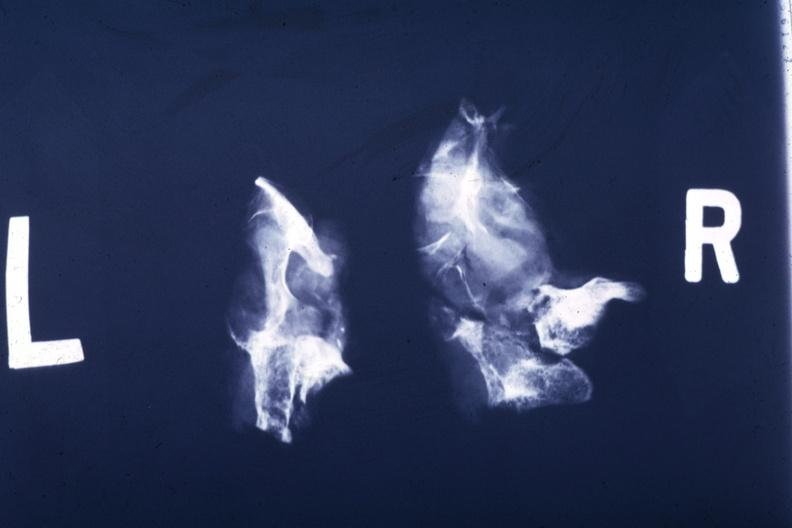what is present?
Answer the question using a single word or phrase. Endocrine 